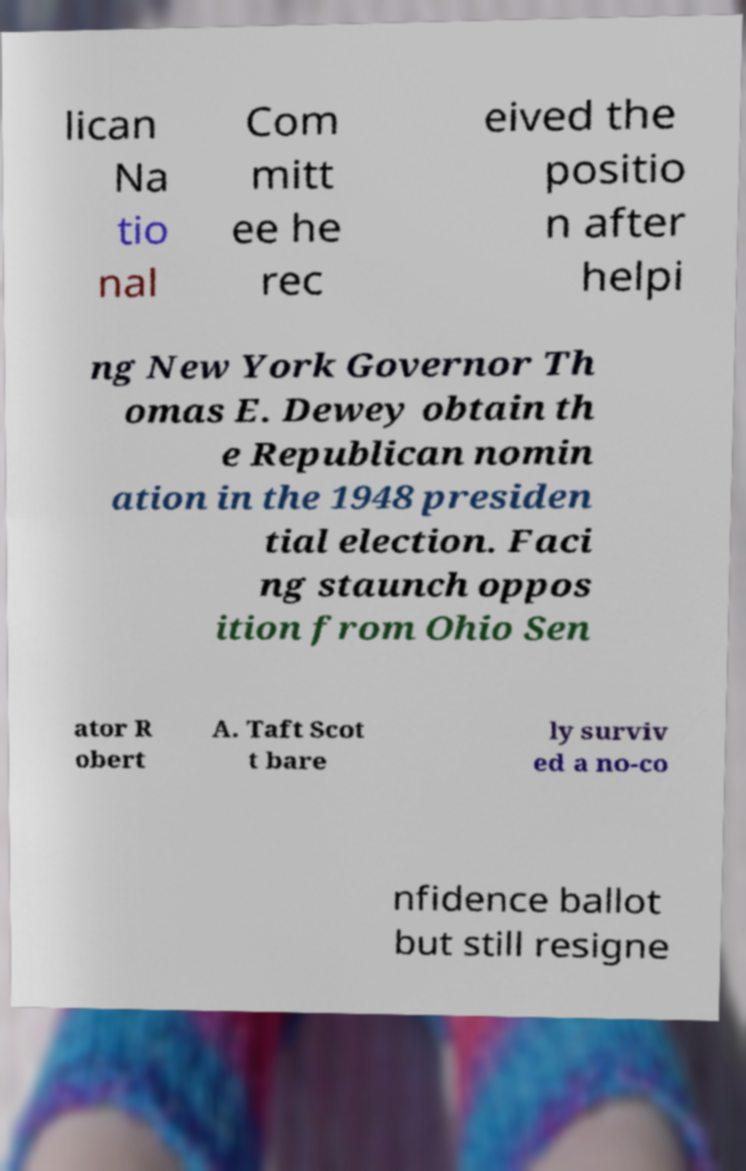Could you assist in decoding the text presented in this image and type it out clearly? lican Na tio nal Com mitt ee he rec eived the positio n after helpi ng New York Governor Th omas E. Dewey obtain th e Republican nomin ation in the 1948 presiden tial election. Faci ng staunch oppos ition from Ohio Sen ator R obert A. Taft Scot t bare ly surviv ed a no-co nfidence ballot but still resigne 